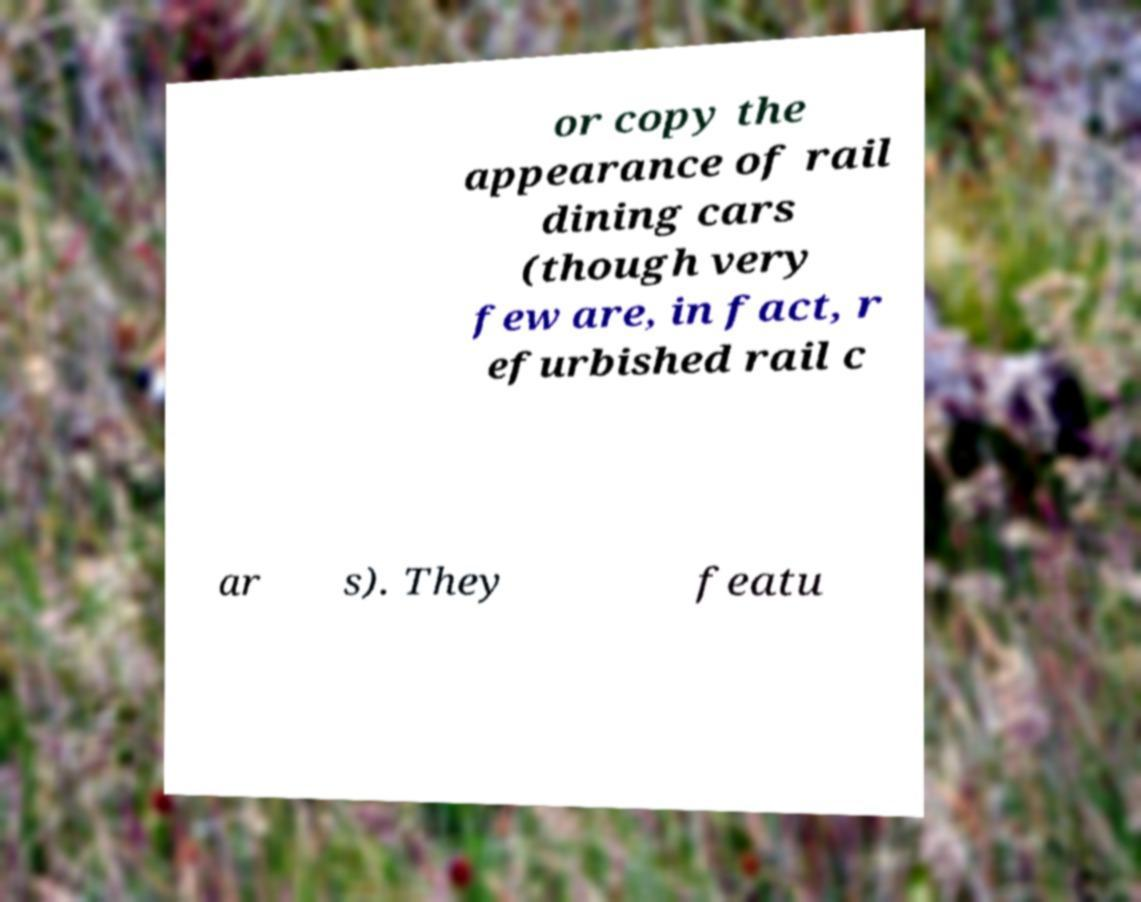Can you accurately transcribe the text from the provided image for me? or copy the appearance of rail dining cars (though very few are, in fact, r efurbished rail c ar s). They featu 